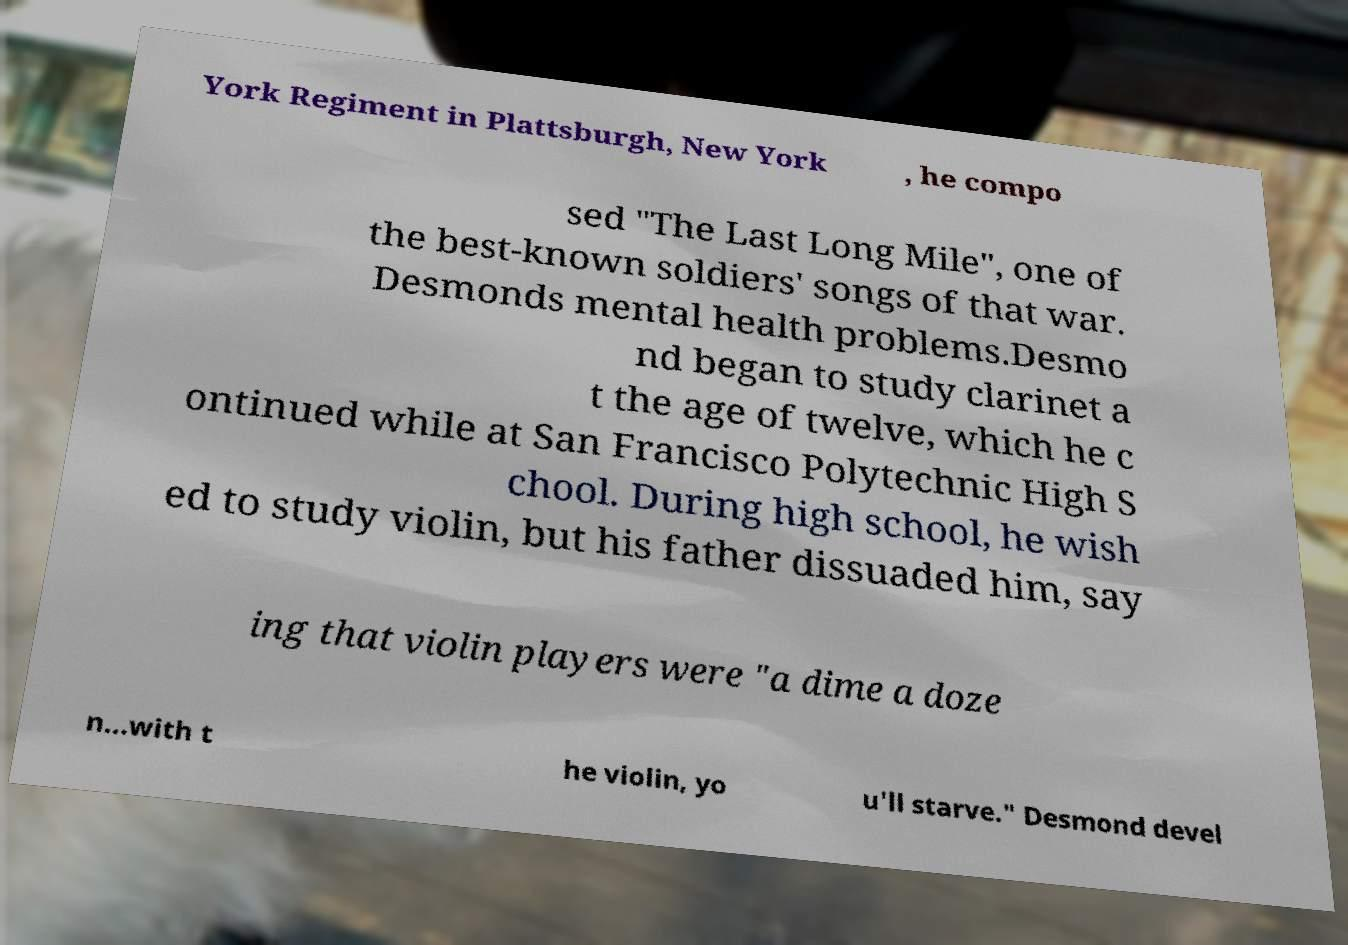There's text embedded in this image that I need extracted. Can you transcribe it verbatim? York Regiment in Plattsburgh, New York , he compo sed "The Last Long Mile", one of the best-known soldiers' songs of that war. Desmonds mental health problems.Desmo nd began to study clarinet a t the age of twelve, which he c ontinued while at San Francisco Polytechnic High S chool. During high school, he wish ed to study violin, but his father dissuaded him, say ing that violin players were "a dime a doze n...with t he violin, yo u'll starve." Desmond devel 